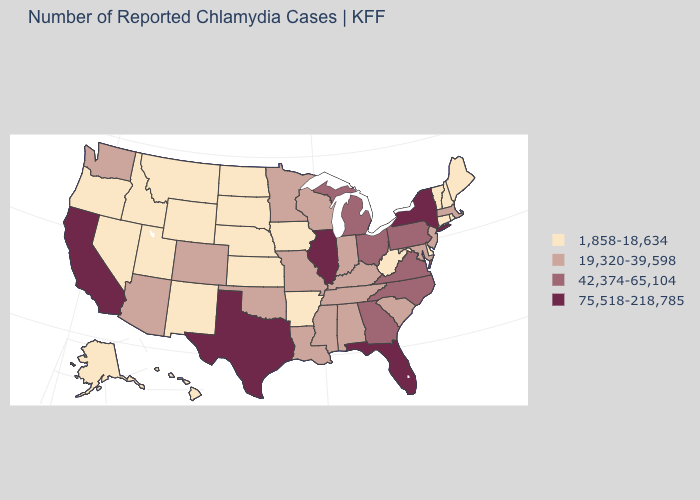Is the legend a continuous bar?
Write a very short answer. No. What is the value of West Virginia?
Quick response, please. 1,858-18,634. What is the value of Indiana?
Write a very short answer. 19,320-39,598. Among the states that border New Hampshire , which have the lowest value?
Concise answer only. Maine, Vermont. Is the legend a continuous bar?
Quick response, please. No. Does Nebraska have the highest value in the MidWest?
Give a very brief answer. No. Does the map have missing data?
Keep it brief. No. Among the states that border Utah , which have the highest value?
Give a very brief answer. Arizona, Colorado. How many symbols are there in the legend?
Short answer required. 4. Name the states that have a value in the range 1,858-18,634?
Give a very brief answer. Alaska, Arkansas, Connecticut, Delaware, Hawaii, Idaho, Iowa, Kansas, Maine, Montana, Nebraska, Nevada, New Hampshire, New Mexico, North Dakota, Oregon, Rhode Island, South Dakota, Utah, Vermont, West Virginia, Wyoming. What is the value of West Virginia?
Quick response, please. 1,858-18,634. What is the lowest value in states that border Maryland?
Short answer required. 1,858-18,634. Does Illinois have the highest value in the MidWest?
Concise answer only. Yes. 